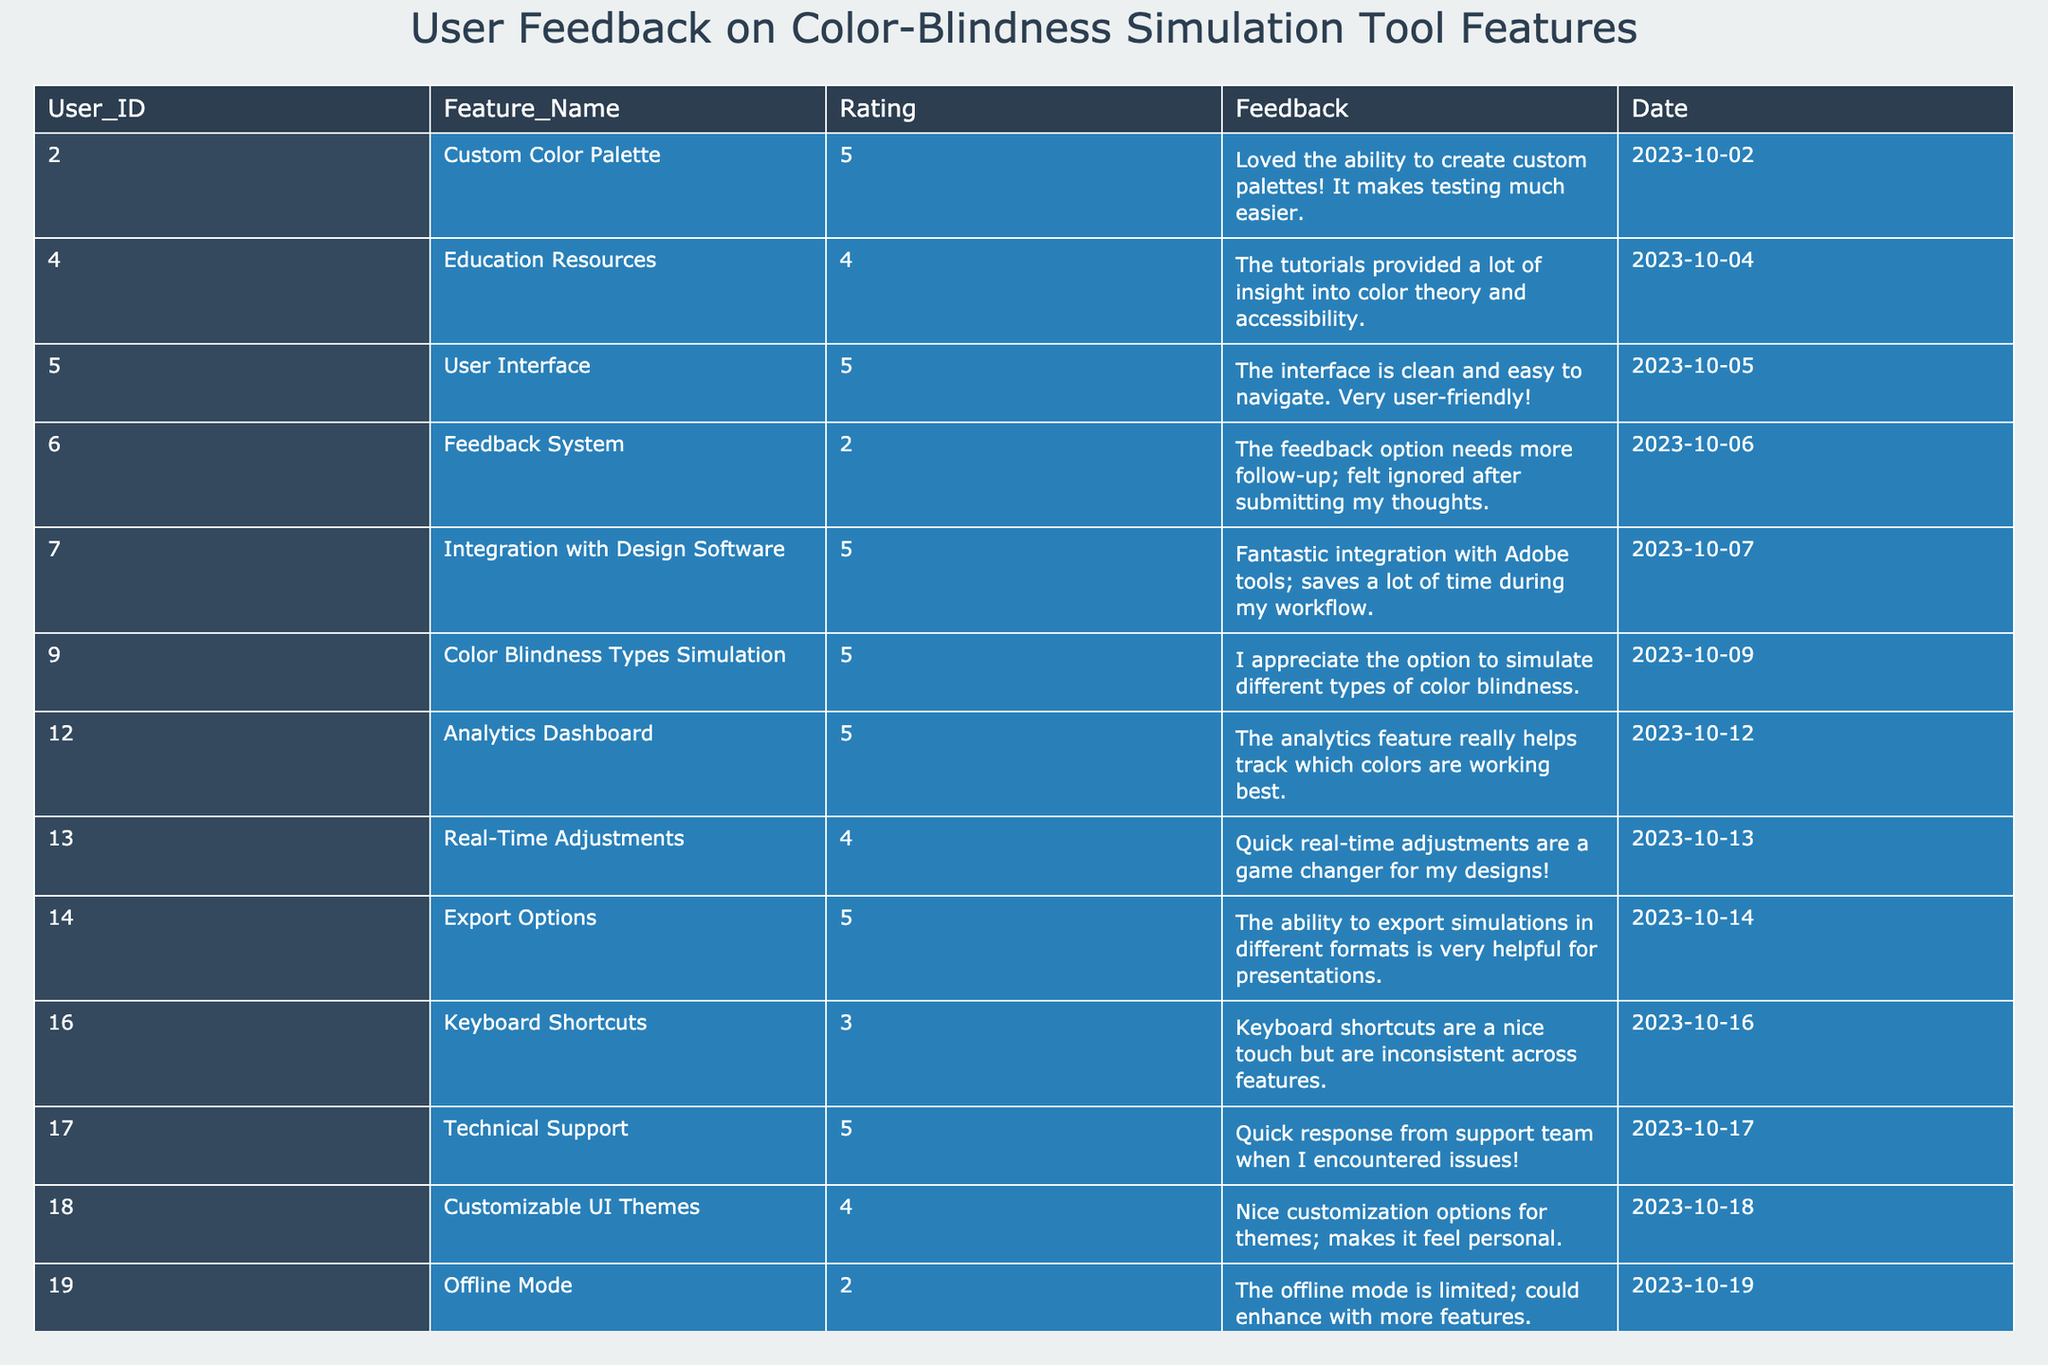What feature received the highest rating? By inspecting the "Rating" column, I find that multiple features received a rating of 5. These features are "Custom Color Palette," "User Interface," "Integration with Design Software," "Color Blindness Types Simulation," "Analytics Dashboard," "Export Options," and "Technical Support."
Answer: Multiple features (7) What user ID provided feedback with the lowest rating? Looking at the "Rating" column, the lowest rating is 2, which corresponds to the user IDs 6 and 19. Thus, the user ID with the lowest rating is 6.
Answer: 6 What is the average rating of the features? To find the average rating, I add up all the ratings: 5 + 4 + 5 + 2 + 5 + 5 + 5 + 4 + 5 + 3 + 5 + 4 + 2 = 57. There are 13 features, so the average is 57/13 = approximately 4.38.
Answer: 4.38 Is there any feedback that mentions integration with design software? Checking the "Feedback" column, I see that user ID 7 provided feedback specifically mentioning the "Integration with Design Software," stating it saves time during their workflow.
Answer: Yes What is the total number of features rated 4 or higher? By scanning through the ratings, the features rated 4 or higher are: "Custom Color Palette," "Education Resources," "User Interface," "Integration with Design Software," "Color Blindness Types Simulation," "Analytics Dashboard," "Real-Time Adjustments," "Export Options," "Technical Support," and "Customizable UI Themes." Counting these gives us a total of 9 features.
Answer: 9 Which feature had the most negative feedback, based on ratings? By analyzing the "Rating" column, the feature "Feedback System" and "Offline Mode" both received a rating of 2. Thus, these features had the most negative feedback based on ratings.
Answer: Feedback System and Offline Mode What was the feedback of user ID 6 regarding the feedback system? User ID 6 gave a rating of 2 and stated in their feedback that the feedback option needs more follow-up and felt ignored after submitting their thoughts.
Answer: The feedback indicates a lack of follow-up Which rating received the highest number of features? Scanning through the ratings, I note that the rating of 5 appears for a total of 7 different features, which is the highest count of features rated the same.
Answer: Rating of 5 Did any users provide feedback on the export options? Yes, user ID 14 provided positive feedback, stating that the ability to export simulations in different formats is very helpful for presentations.
Answer: Yes 